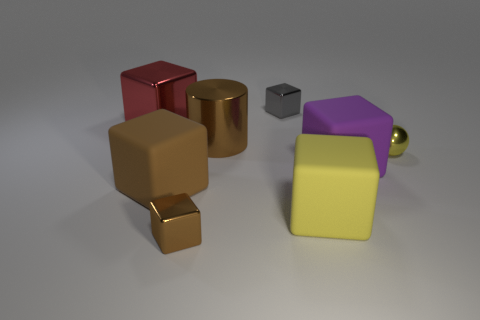Subtract all small cubes. How many cubes are left? 4 Subtract all red cubes. How many cubes are left? 5 Subtract 1 blocks. How many blocks are left? 5 Subtract all gray cubes. Subtract all cyan spheres. How many cubes are left? 5 Add 1 blue matte cylinders. How many objects exist? 9 Subtract all blocks. How many objects are left? 2 Add 2 red shiny objects. How many red shiny objects are left? 3 Add 3 red cubes. How many red cubes exist? 4 Subtract 1 brown cylinders. How many objects are left? 7 Subtract all big brown blocks. Subtract all cubes. How many objects are left? 1 